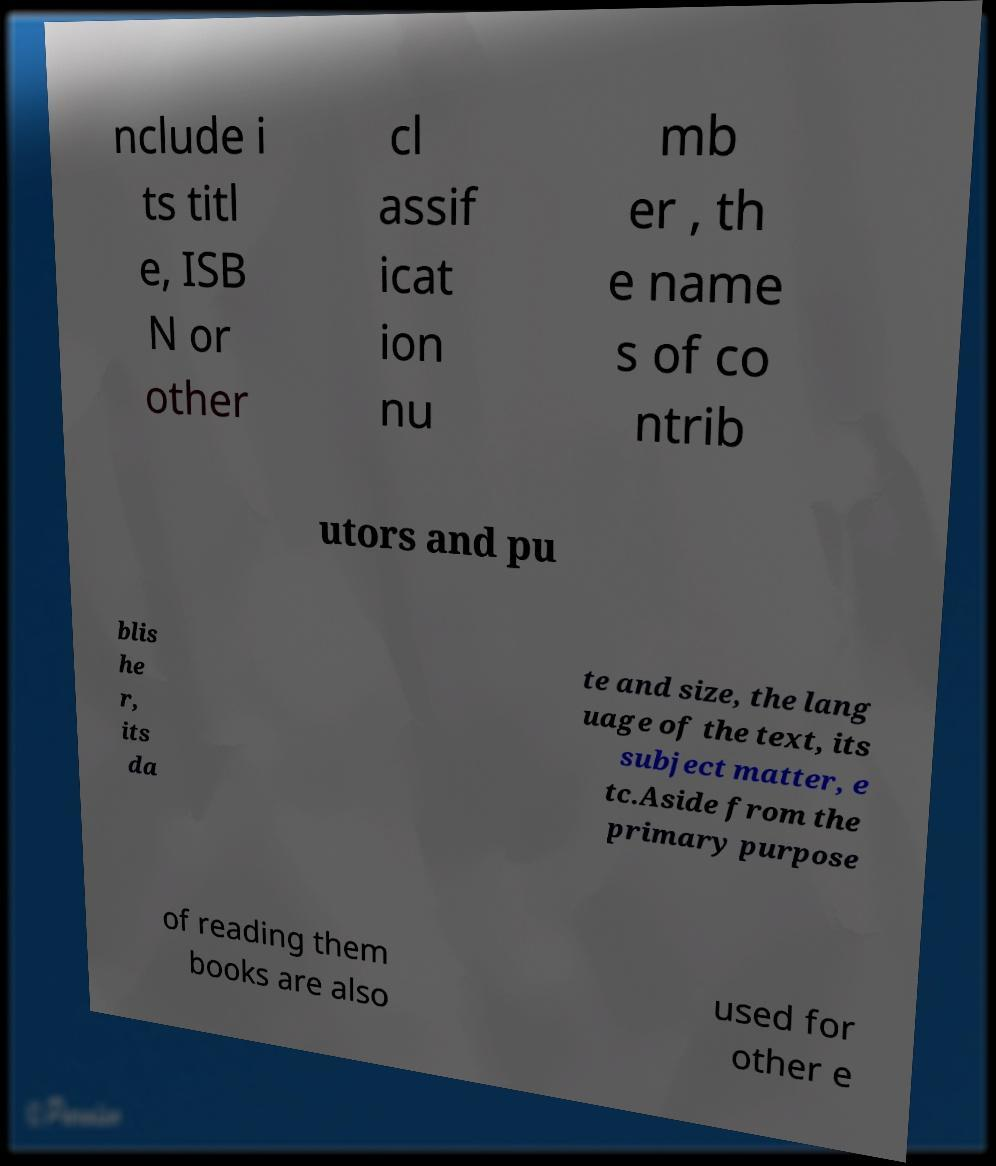Can you accurately transcribe the text from the provided image for me? nclude i ts titl e, ISB N or other cl assif icat ion nu mb er , th e name s of co ntrib utors and pu blis he r, its da te and size, the lang uage of the text, its subject matter, e tc.Aside from the primary purpose of reading them books are also used for other e 